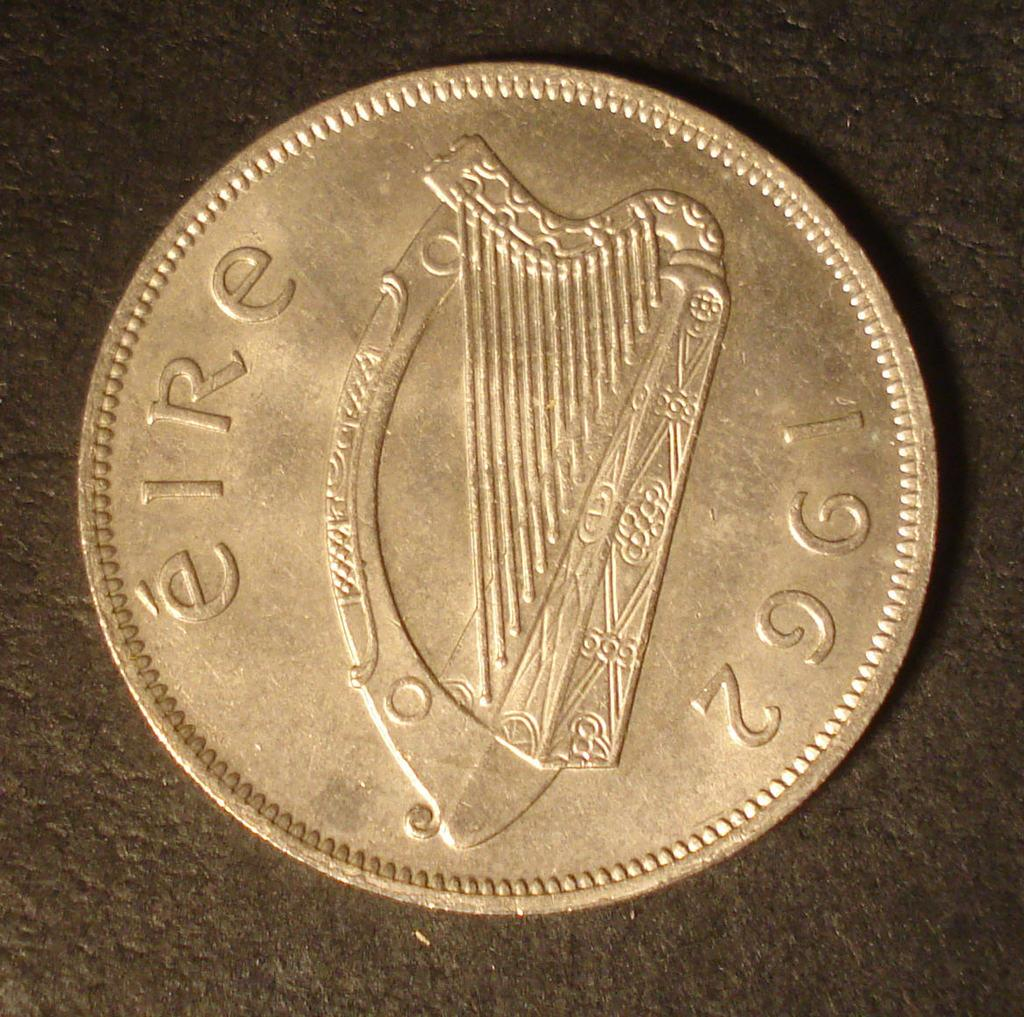Provide a one-sentence caption for the provided image. an eire 1962 coin with a harp on it. 